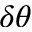<formula> <loc_0><loc_0><loc_500><loc_500>\delta \theta</formula> 